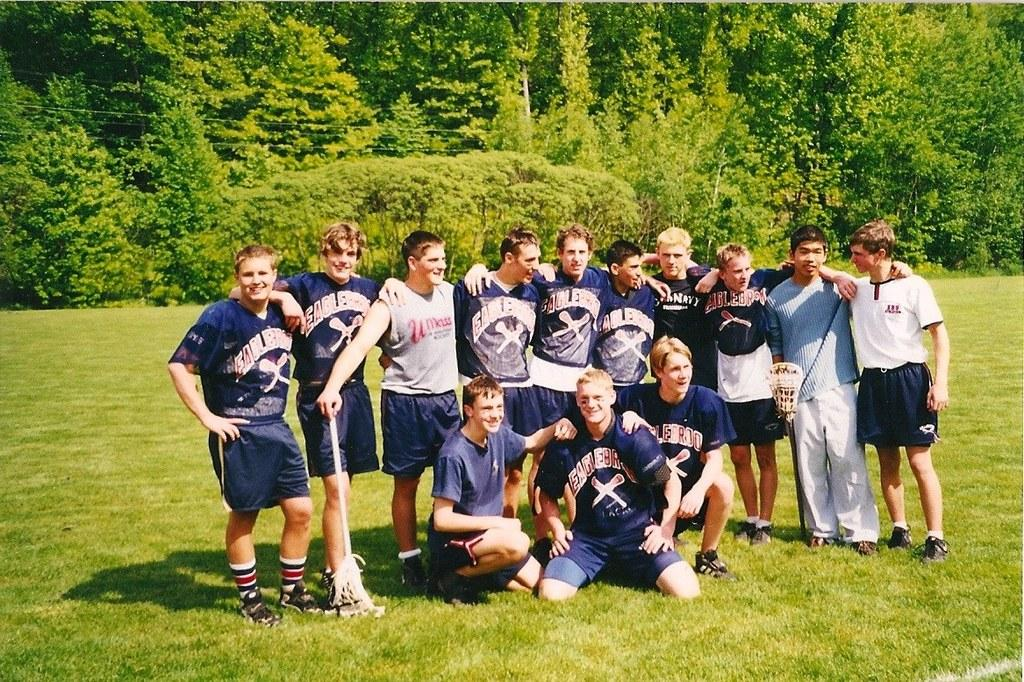What can be seen in the image? There is a group of people in the image. What are the people wearing? The people are wearing jerseys. What type of surface is visible in the image? There is grass on the floor in the image. What other natural elements can be seen in the image? There are trees in the image. Can you describe the experience of the rat in the image? There is no rat present in the image, so it is not possible to describe its experience. 